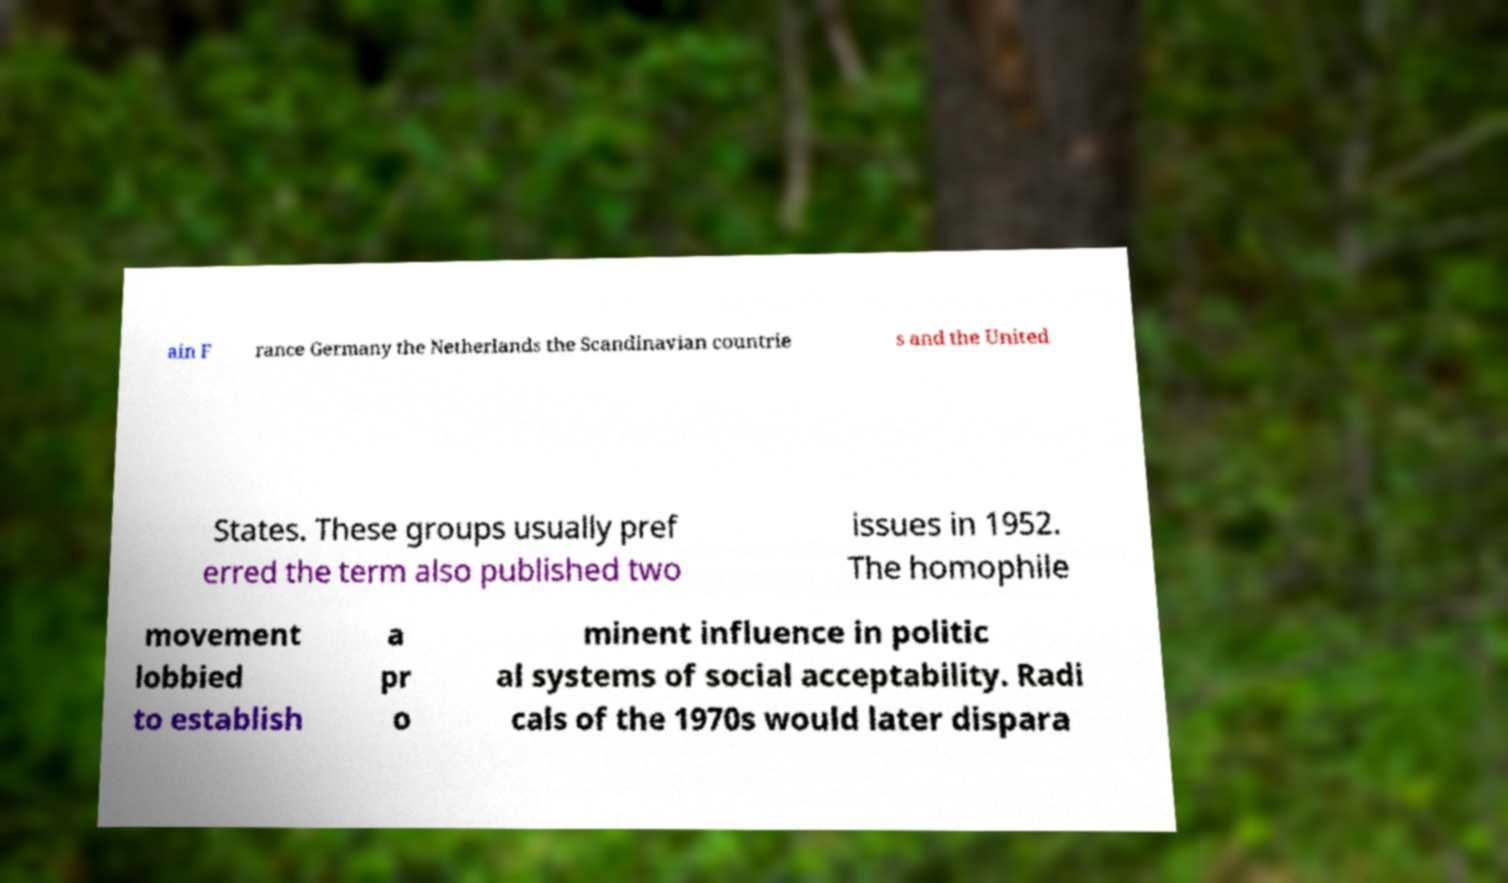There's text embedded in this image that I need extracted. Can you transcribe it verbatim? ain F rance Germany the Netherlands the Scandinavian countrie s and the United States. These groups usually pref erred the term also published two issues in 1952. The homophile movement lobbied to establish a pr o minent influence in politic al systems of social acceptability. Radi cals of the 1970s would later dispara 